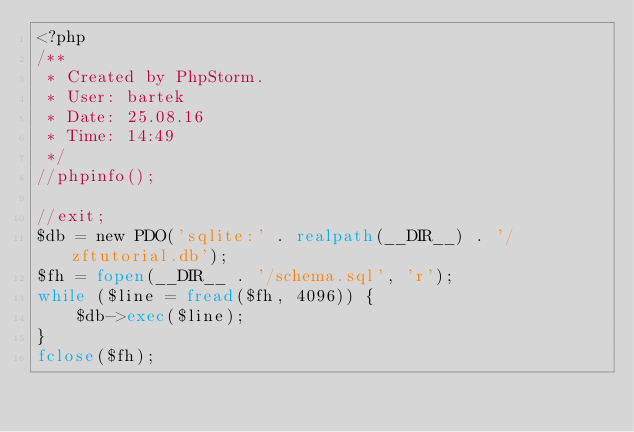Convert code to text. <code><loc_0><loc_0><loc_500><loc_500><_PHP_><?php
/**
 * Created by PhpStorm.
 * User: bartek
 * Date: 25.08.16
 * Time: 14:49
 */
//phpinfo();

//exit;
$db = new PDO('sqlite:' . realpath(__DIR__) . '/zftutorial.db');
$fh = fopen(__DIR__ . '/schema.sql', 'r');
while ($line = fread($fh, 4096)) {
    $db->exec($line);
}
fclose($fh);</code> 